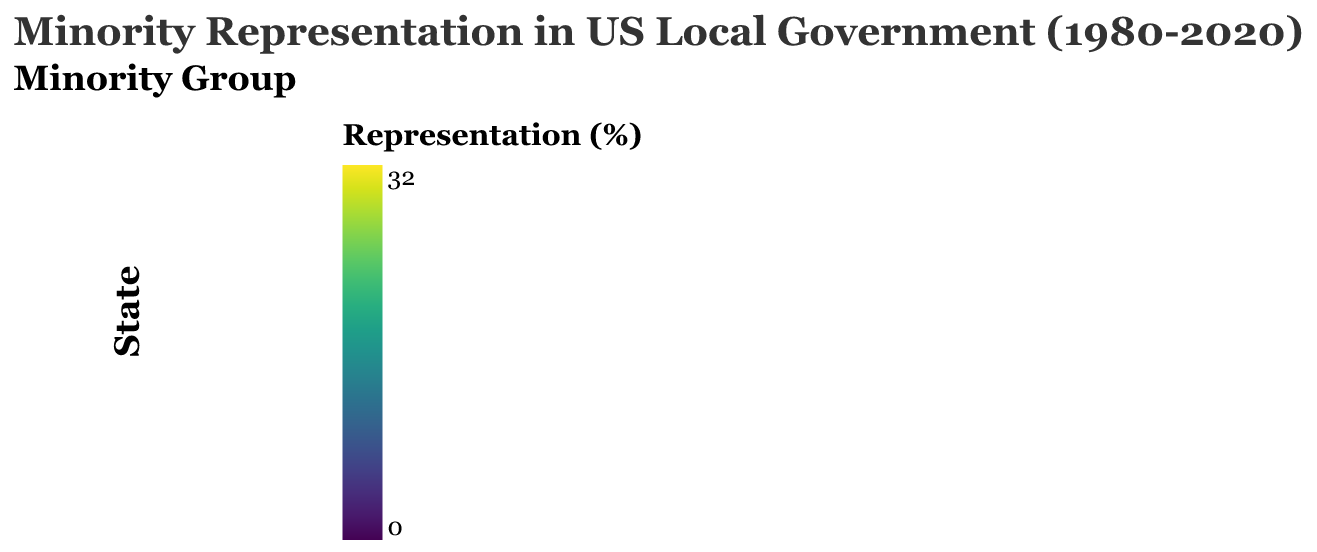What is the title of the figure? The title is normally found at the top of the figure, representing the overall theme or subject of the data being visualized. The title in this figure reads "Minority Representation in US Local Government (1980-2020)."
Answer: Minority Representation in US Local Government (1980-2020) Which state had the highest African American representation in 2020? Examine the heatmap for the year 2020 and look at the African American category across all states. The state with the darkest shade has the highest representation, which is Georgia.
Answer: Georgia How did Hispanic representation in California change from 1980 to 2020? Locate California in the heatmap and compare the color intensity for Hispanic representation from the year 1980 to 2020. The color becomes significantly darker, indicating an increase from 10% in 1980 to 30% in 2020.
Answer: Increased by 20 percentage points (from 10% to 30%) Compare Asian representation between Texas and New York in the 2000s. Which state had a higher representation? Find the two states in the heatmap for the decade 2000 and compare the Asian representation color shades. Texas had 4% and New York had 8%, so New York had a higher representation.
Answer: New York What is the trend in Native American representation in Alabama from 1980 to 2020? Observe the color change in the Native American representation category for Alabama from 1980 through 2020. The color becomes progressively darker, showing an increase from 0.2% to 1.5%.
Answer: Increasing Which minority group saw the most significant increase in representation in Texas from 1980 to 2020? For Texas, look at all four minority categories for the decades 1980 and 2020. The Hispanic group shows the most noticeable color change from 12% in 1980 to 32% in 2020.
Answer: Hispanic How did Asian representation change in Georgia over the decades? Observe the trend for the Asian representation category in Georgia from 1980 to 2020. The color gradually darkens, indicating an increase from 1% in 1980 to 4% in 2020.
Answer: Increased by 3 percentage points (from 1% to 4%) Which state had the highest Native American representation in 2010? Inspect the 2010 column for the Native American representation category to find the darkest color shade across all states. Both California and New York have the highest representation at 2%.
Answer: California and New York Is African American representation in California in 2020 greater than in Texas in 2000? Compare the color intensity for African American representation in California in 2020 and Texas in 2000. California in 2020 has 15% and Texas in 2000 has 12%, so yes, California's representation is greater.
Answer: Yes What is the average Native American representation in New York from 1980 to 2020? List the percentages for Native American representation in New York for each decade: 1980 (1%), 1990 (1%), 2000 (2%), 2010 (2%), and 2020 (3%). Calculate the sum (1+1+2+2+3=9) and divide by the number of decades (5).
Answer: 1.8% 